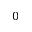Convert formula to latex. <formula><loc_0><loc_0><loc_500><loc_500>0</formula> 